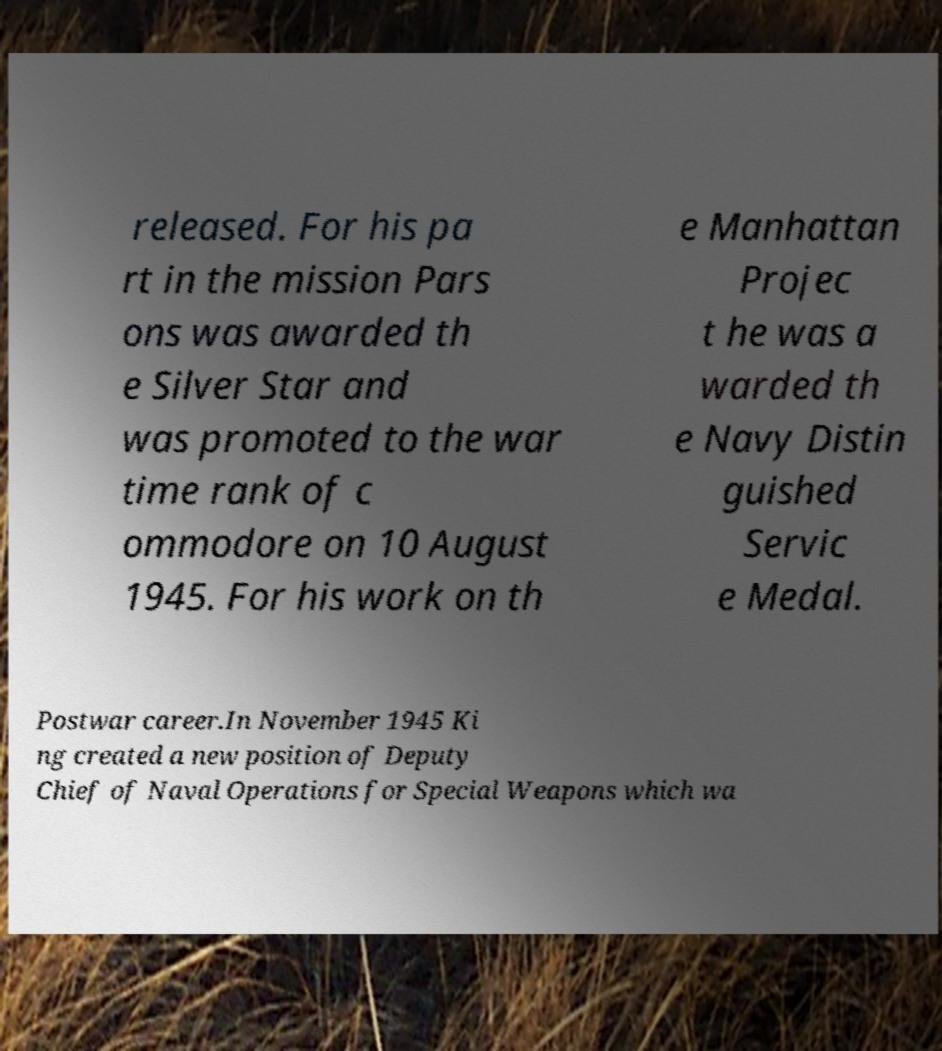Can you read and provide the text displayed in the image?This photo seems to have some interesting text. Can you extract and type it out for me? released. For his pa rt in the mission Pars ons was awarded th e Silver Star and was promoted to the war time rank of c ommodore on 10 August 1945. For his work on th e Manhattan Projec t he was a warded th e Navy Distin guished Servic e Medal. Postwar career.In November 1945 Ki ng created a new position of Deputy Chief of Naval Operations for Special Weapons which wa 